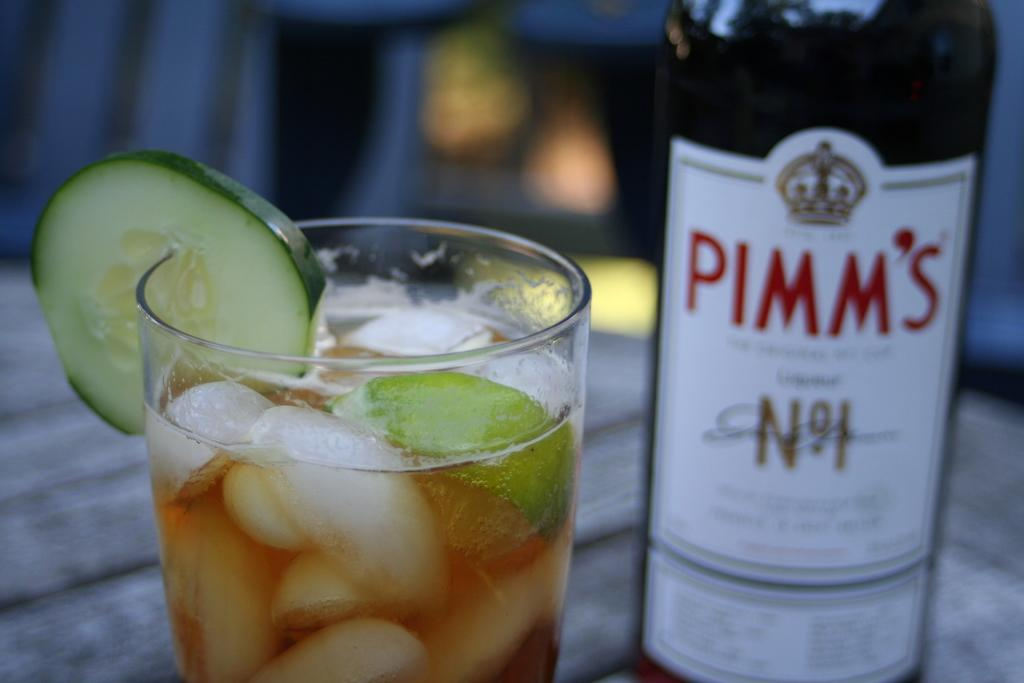Provide a one-sentence caption for the provided image. a beer bottle with Pimm's written on it. 